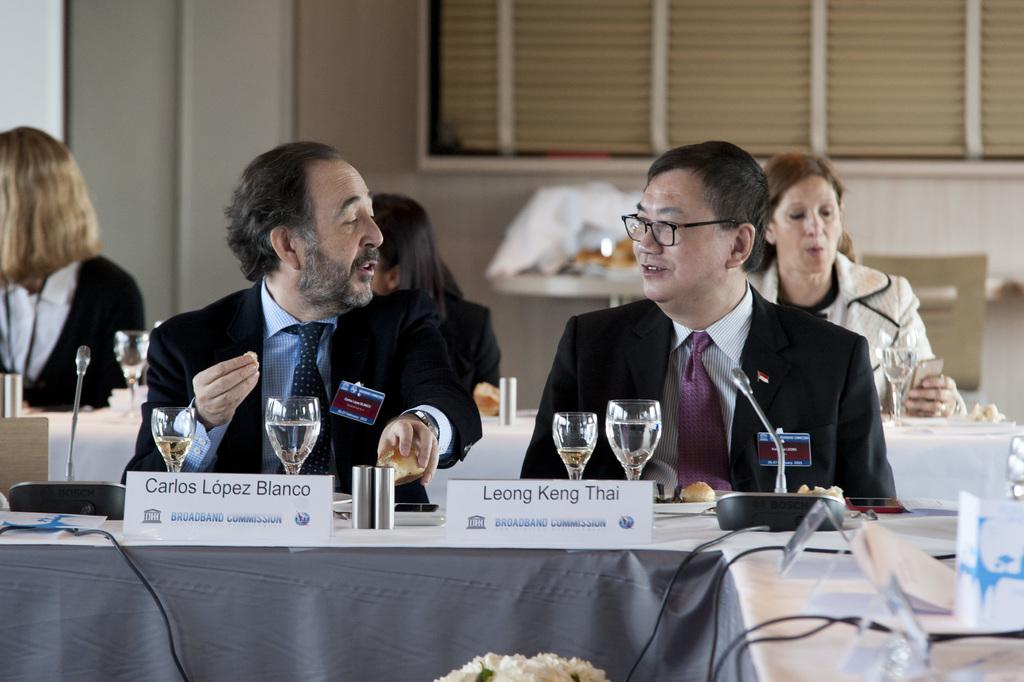<image>
Relay a brief, clear account of the picture shown. Leong Keng Thai is sitting at a table next to Carlos Lopez Bianco. 